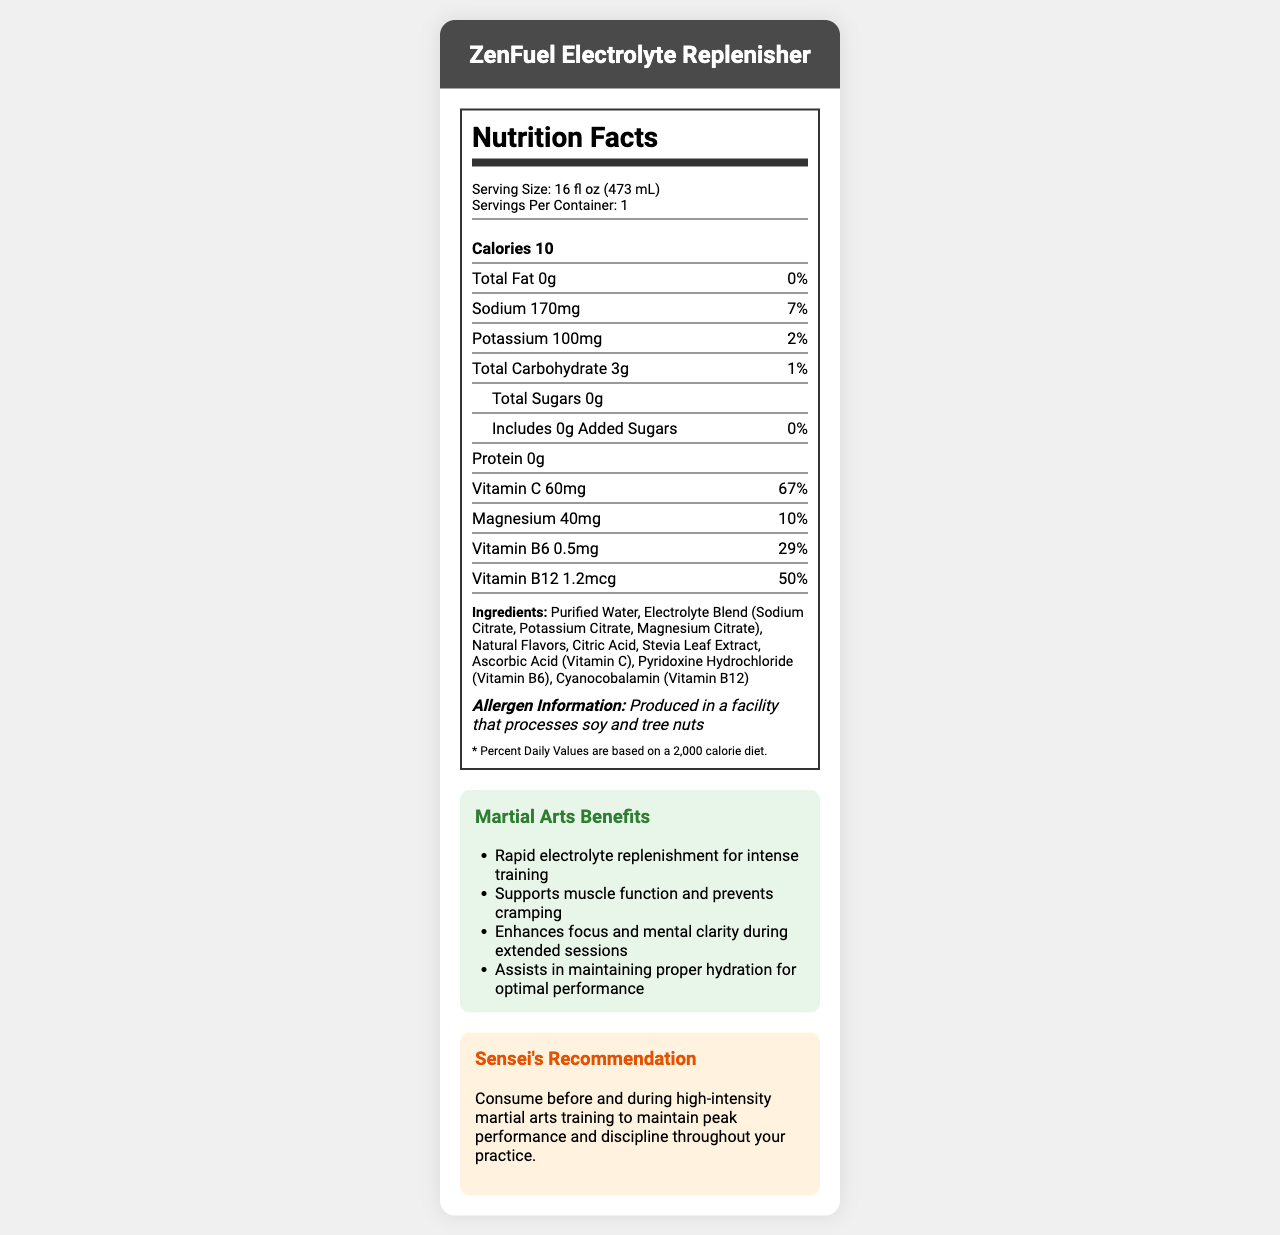what is the serving size for ZenFuel Electrolyte Replenisher? The serving size is listed under the "Serving Size" label in the Nutrition Facts section.
Answer: 16 fl oz (473 mL) how many servings are there per container? The document states "Servings Per Container: 1" in the Nutrition Facts section.
Answer: 1 what is the calorie count per serving? Calories are listed in the bold Nutrition Facts section.
Answer: 10 how much sodium does ZenFuel Electrolyte Replenisher contain per serving? The amount of sodium per serving is found in the Nutrition Facts section under "Sodium."
Answer: 170mg does ZenFuel Electrolyte Replenisher contain any protein? The protein content is listed as "0g" in the Nutrition Facts section.
Answer: No how much Vitamin C is in each serving of ZenFuel Electrolyte Replenisher? The Vitamin C content is specified under "Vitamin C" in the Nutrition Facts section.
Answer: 60mg which ingredient in ZenFuel Electrolyte Replenisher is a natural sweetener? A. Sodium Citrate B. Stevia Leaf Extract C. Citric Acid Stevia Leaf Extract is the natural sweetener listed in the ingredients section.
Answer: B what benefit does ZenFuel Electrolyte Replenisher provide for martial arts training? A. Weight loss B. Rapid electrolyte replenishment C. Muscle building The benefits section mentions "Rapid electrolyte replenishment for intense training."
Answer: B is ZenFuel Electrolyte Replenisher produced in a facility that processes allergens? The allergen information states that it is produced in a facility that processes soy and tree nuts.
Answer: Yes does ZenFuel Electrolyte Replenisher contain any added sugars? The total sugars section mentions "Includes 0g Added Sugars."
Answer: No summarize the main purpose of the document. The document aims to inform users about the nutritional content and benefits of the product, emphasizing its suitability for martial arts activities.
Answer: The document provides detailed nutrition information for ZenFuel Electrolyte Replenisher, a sports drink designed for hydration and electrolyte replenishment during martial arts training. It includes servings, calories, ingredients, and specific benefits for martial arts practitioners, along with a recommendation from a sensei. is there enough information in the document to know the exact manufacturing location of ZenFuel Electrolyte Replenisher? The document does not provide any information regarding the manufacturing location.
Answer: No 